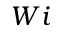<formula> <loc_0><loc_0><loc_500><loc_500>W i</formula> 